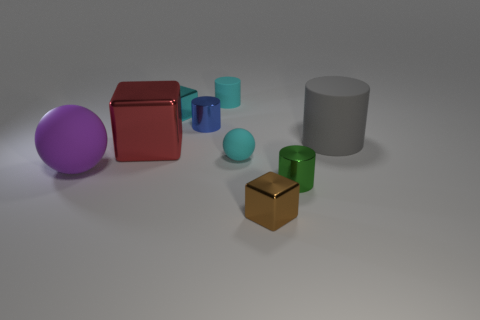Subtract all tiny cyan rubber cylinders. How many cylinders are left? 3 Subtract 1 cubes. How many cubes are left? 2 Subtract all blue cylinders. Subtract all red spheres. How many cylinders are left? 3 Subtract all purple balls. How many red blocks are left? 1 Subtract all cyan rubber cylinders. Subtract all tiny rubber cylinders. How many objects are left? 7 Add 1 big gray cylinders. How many big gray cylinders are left? 2 Add 8 red matte balls. How many red matte balls exist? 8 Subtract all red cubes. How many cubes are left? 2 Subtract 0 brown cylinders. How many objects are left? 9 Subtract all cubes. How many objects are left? 6 